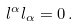Convert formula to latex. <formula><loc_0><loc_0><loc_500><loc_500>l ^ { \alpha } l _ { \alpha } = 0 \, .</formula> 